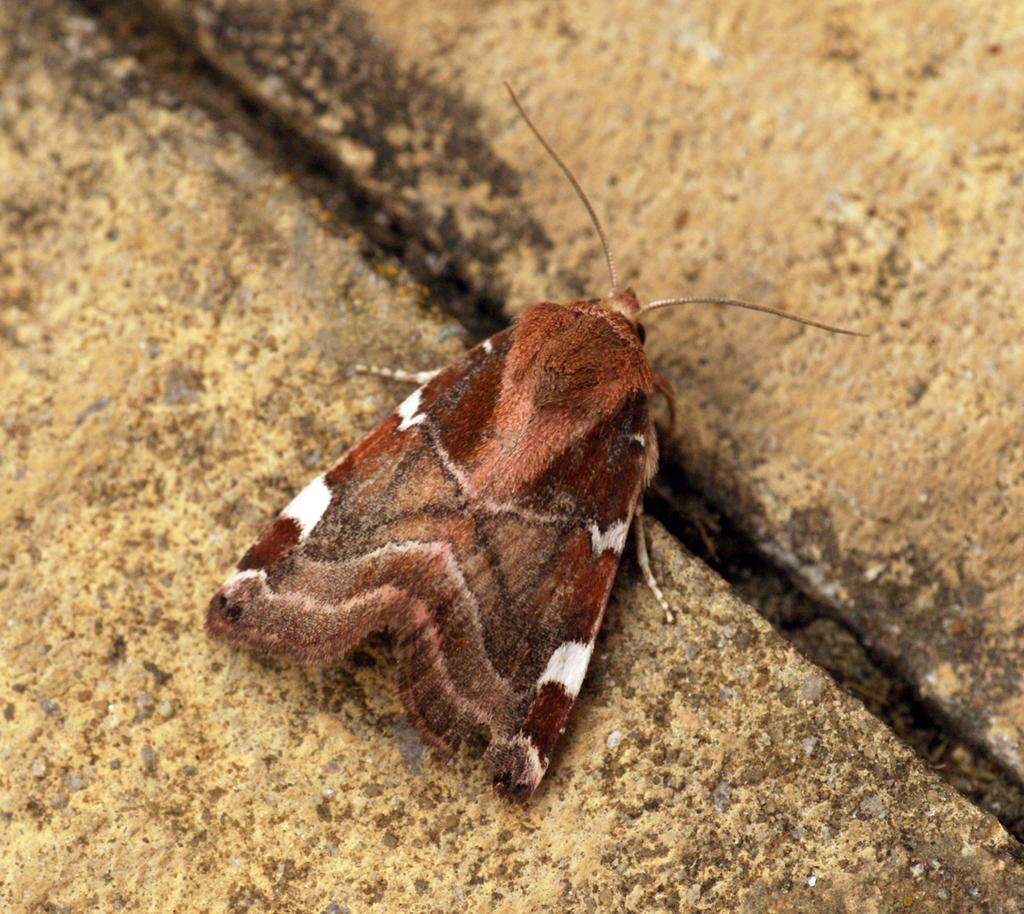What type of animal can be seen in the image? There is a butterfly in the image. Where is the butterfly located in the image? The butterfly is standing on the floor. What type of lunchroom is visible in the image? There is no lunchroom present in the image; it features a butterfly standing on the floor. Can you describe the wave pattern on the butterfly's wings in the image? There is no wave pattern visible on the butterfly's wings in the image; it is a simple butterfly standing on the floor. 